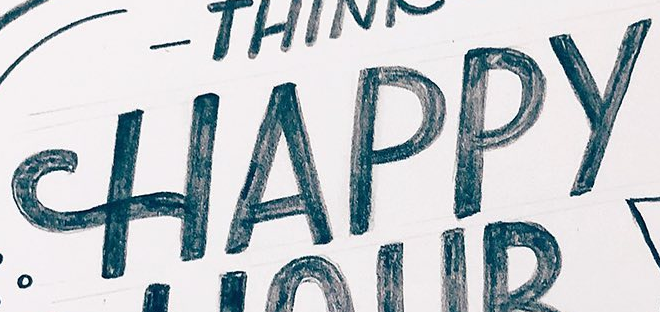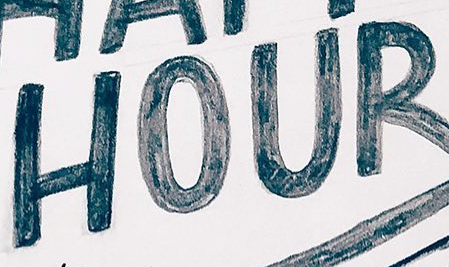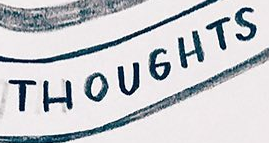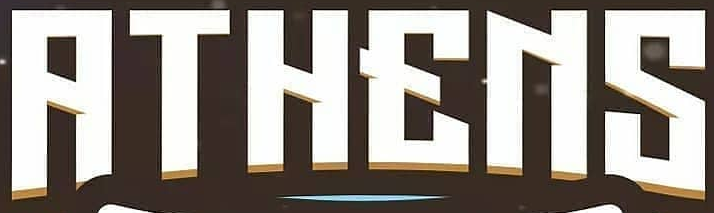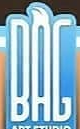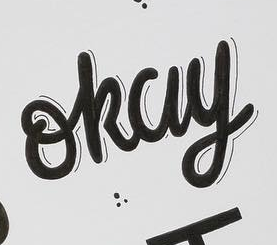What words are shown in these images in order, separated by a semicolon? HAPPY; HOUR; THOUGHTS; RTHENS; BAG; okay 